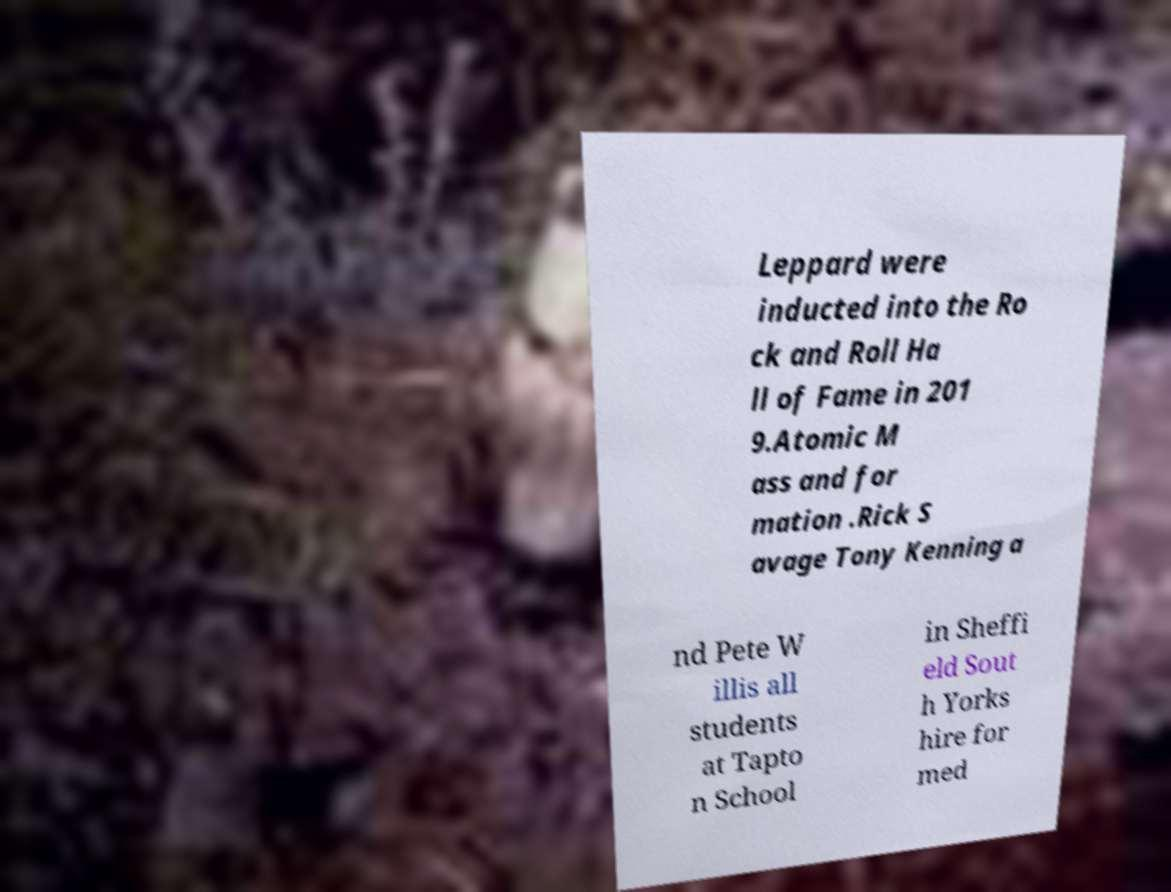Can you read and provide the text displayed in the image?This photo seems to have some interesting text. Can you extract and type it out for me? Leppard were inducted into the Ro ck and Roll Ha ll of Fame in 201 9.Atomic M ass and for mation .Rick S avage Tony Kenning a nd Pete W illis all students at Tapto n School in Sheffi eld Sout h Yorks hire for med 